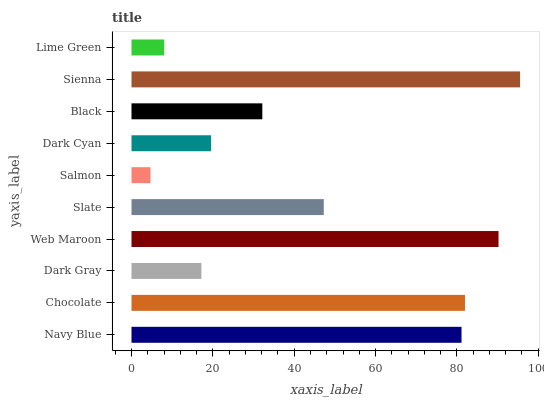Is Salmon the minimum?
Answer yes or no. Yes. Is Sienna the maximum?
Answer yes or no. Yes. Is Chocolate the minimum?
Answer yes or no. No. Is Chocolate the maximum?
Answer yes or no. No. Is Chocolate greater than Navy Blue?
Answer yes or no. Yes. Is Navy Blue less than Chocolate?
Answer yes or no. Yes. Is Navy Blue greater than Chocolate?
Answer yes or no. No. Is Chocolate less than Navy Blue?
Answer yes or no. No. Is Slate the high median?
Answer yes or no. Yes. Is Black the low median?
Answer yes or no. Yes. Is Navy Blue the high median?
Answer yes or no. No. Is Salmon the low median?
Answer yes or no. No. 